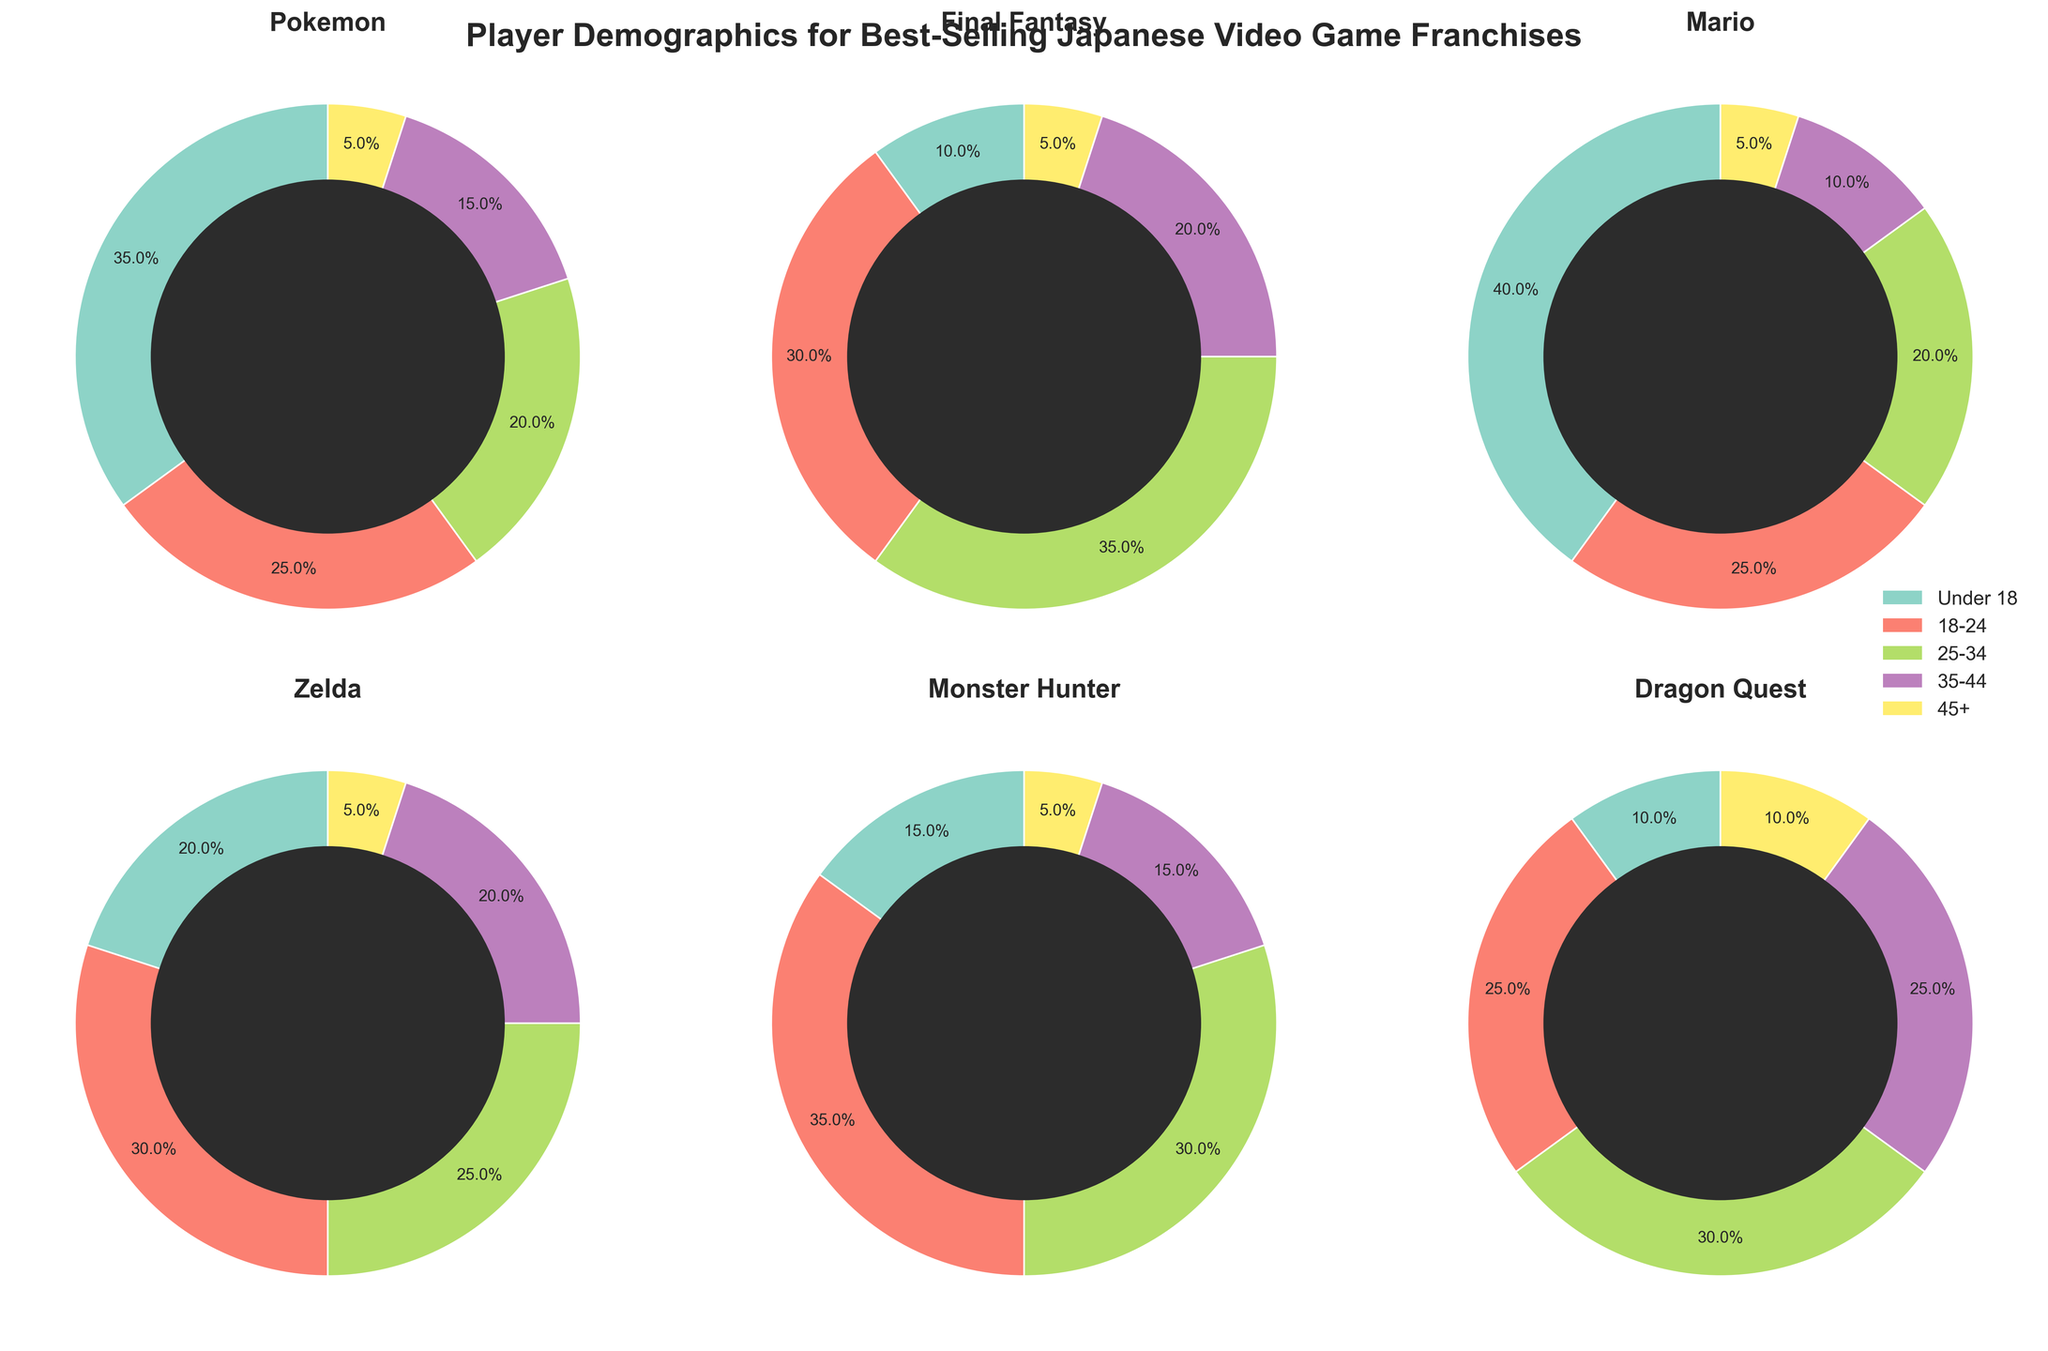Which franchise has the largest proportion of players under 18? To determine the franchise with the largest proportion of players under 18, compare the percentages of the "Under 18" age group for each franchise by looking at the pie chart. Pokemon has 35%, Final Fantasy has 10%, Mario has 40%, Zelda has 20%, Monster Hunter has 15%, and Dragon Quest has 10%. Mario has the highest percentage of 40%.
Answer: Mario What's the combined percentage of players aged 25-34 for both Final Fantasy and Zelda? First, find the percentage of the 25-34 age group for both Final Fantasy and Zelda. Final Fantasy has 35% and Zelda has 25%. Add these two percentages together: 35% + 25% = 60%.
Answer: 60% Which franchise has the smallest proportion of players aged 45 and above? Examine the slices representing the 45+ age group across all pie charts. Each franchise has the proportion as follows: Pokemon (5%), Final Fantasy (5%), Mario (5%), Zelda (5%), Monster Hunter (5%), Dragon Quest (10%). All except Dragon Quest have an equal smallest proportion of 5%.
Answer: Pokemon, Final Fantasy, Mario, Zelda, Monster Hunter How does the proportion of players aged 18-24 in Monster Hunter compare to that in Dragon Quest? Check the pie chart sections for the 18-24 age group in both Monster Hunter and Dragon Quest. Monster Hunter has 35%, while Dragon Quest has 25%. Since 35% is greater than 25%, Monster Hunter has a larger proportion.
Answer: Monster Hunter has a larger proportion What's the total percentage of players aged 35-44 across all the franchises? Sum the percentages of the 35-44 age group for each franchise: Pokemon (15%) + Final Fantasy (20%) + Mario (10%) + Zelda (20%) + Monster Hunter (15%) + Dragon Quest (25%). Calculate the total: 15% + 20% + 10% + 20% + 15% + 25% = 105%.
Answer: 105% Which franchise has the most balanced age distribution? To determine the most balanced distribution, look for the pie chart with age group percentages that are closest to each other. Pokemon (35%, 25%, 20%, 15%, 5%), Final Fantasy (10%, 30%, 35%, 20%, 5%), Mario (40%, 25%, 20%, 10%, 5%), Zelda (20%, 30%, 25%, 20%, 5%), Monster Hunter (15%, 35%, 30%, 15%, 5%), Dragon Quest (10%, 25%, 30%, 25%, 10%). Pokemon has the closest distribution with balanced segments.
Answer: Pokemon 